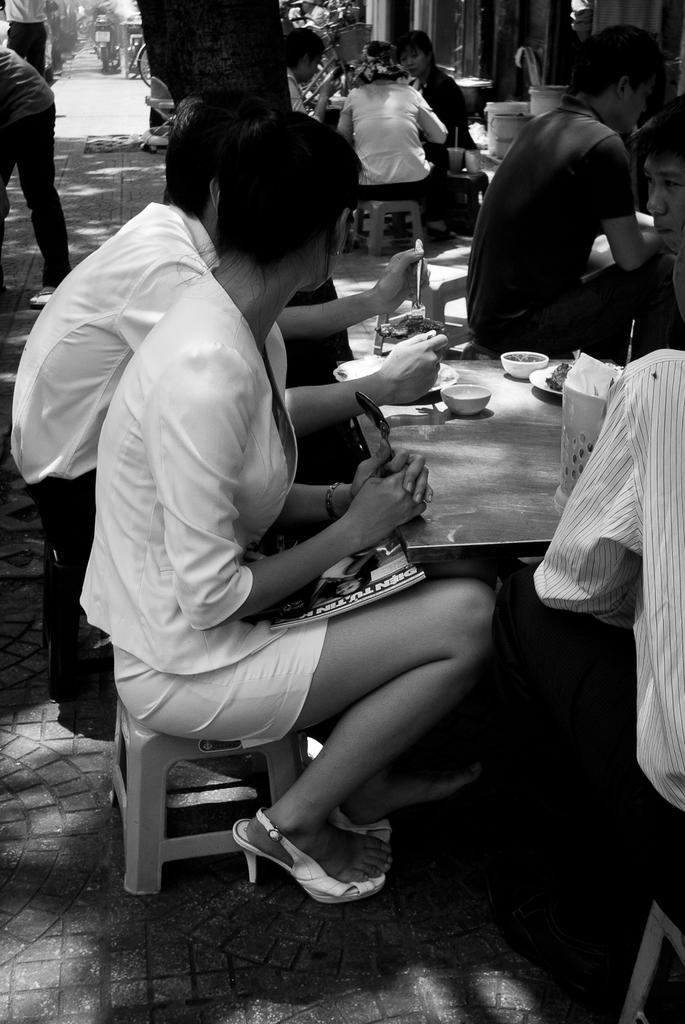What are the persons in the image doing? The persons in the image are sitting on stools. What is present in the image besides the persons? There is a table in the image. What items can be seen on the table? There are plates and bowls on the table. Can you see any signs of debt on the table in the image? There is no indication of debt present on the table in the image. Are there any sidewalks visible in the image? There is no sidewalk present in the image; it appears to be an indoor setting. 